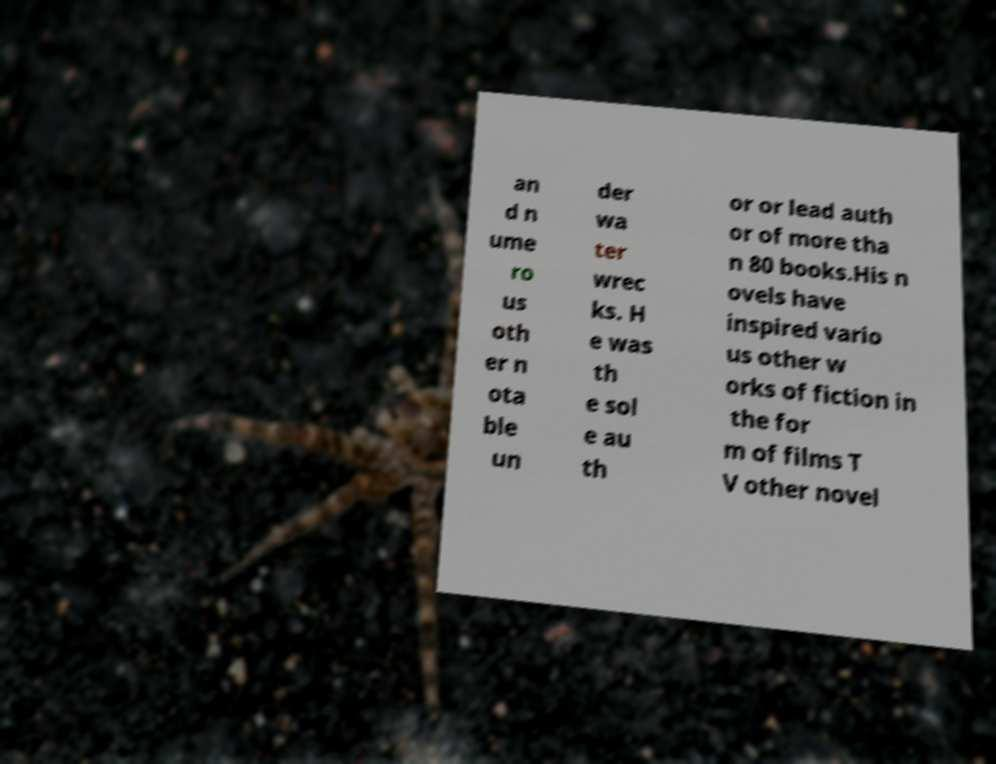Can you accurately transcribe the text from the provided image for me? an d n ume ro us oth er n ota ble un der wa ter wrec ks. H e was th e sol e au th or or lead auth or of more tha n 80 books.His n ovels have inspired vario us other w orks of fiction in the for m of films T V other novel 